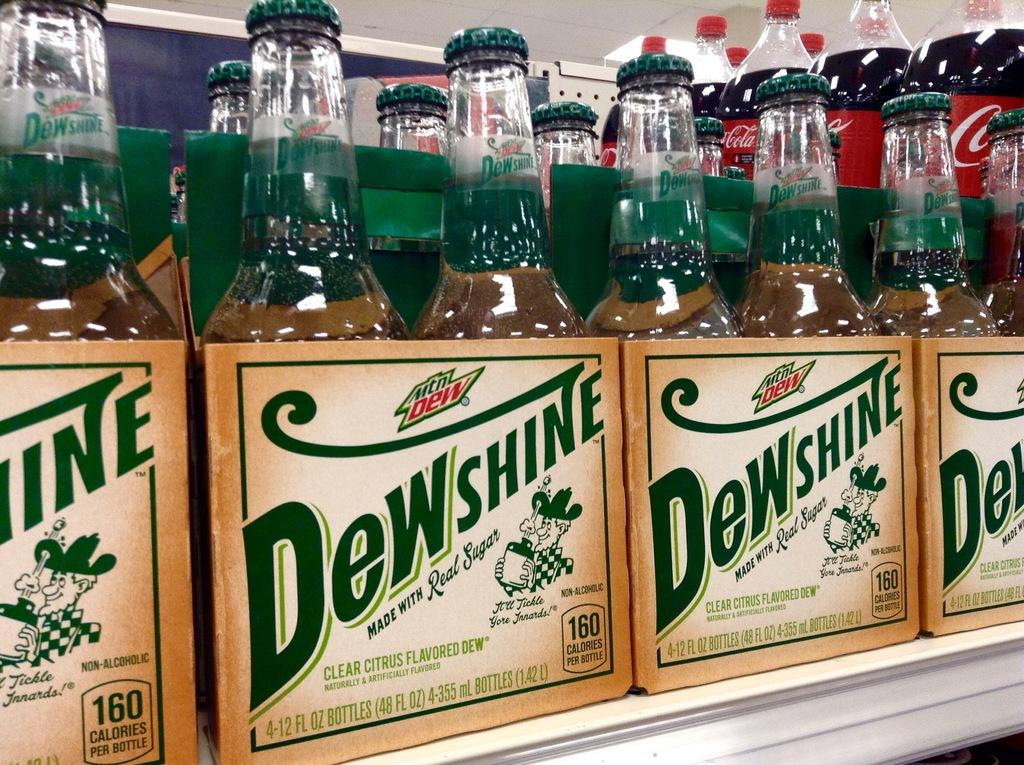<image>
Give a short and clear explanation of the subsequent image. packs of glass bottles of dewshine mountain dew 